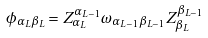Convert formula to latex. <formula><loc_0><loc_0><loc_500><loc_500>\phi _ { \alpha _ { L } \beta _ { L } } = Z _ { \alpha _ { L } } ^ { \alpha _ { L - 1 } } \omega _ { \alpha _ { L - 1 } \beta _ { L - 1 } } Z _ { \beta _ { L } } ^ { \beta _ { L - 1 } }</formula> 